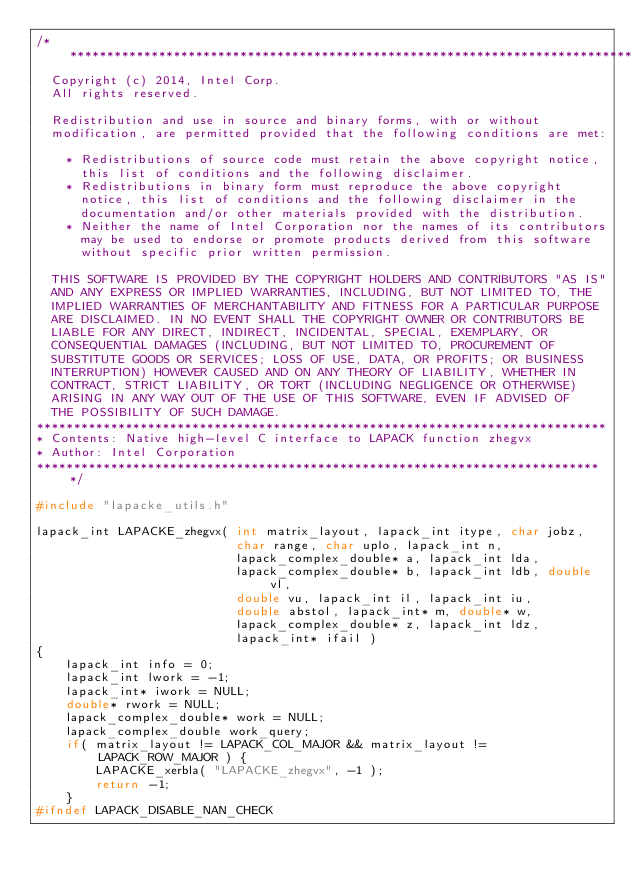Convert code to text. <code><loc_0><loc_0><loc_500><loc_500><_C_>/*****************************************************************************
  Copyright (c) 2014, Intel Corp.
  All rights reserved.

  Redistribution and use in source and binary forms, with or without
  modification, are permitted provided that the following conditions are met:

    * Redistributions of source code must retain the above copyright notice,
      this list of conditions and the following disclaimer.
    * Redistributions in binary form must reproduce the above copyright
      notice, this list of conditions and the following disclaimer in the
      documentation and/or other materials provided with the distribution.
    * Neither the name of Intel Corporation nor the names of its contributors
      may be used to endorse or promote products derived from this software
      without specific prior written permission.

  THIS SOFTWARE IS PROVIDED BY THE COPYRIGHT HOLDERS AND CONTRIBUTORS "AS IS"
  AND ANY EXPRESS OR IMPLIED WARRANTIES, INCLUDING, BUT NOT LIMITED TO, THE
  IMPLIED WARRANTIES OF MERCHANTABILITY AND FITNESS FOR A PARTICULAR PURPOSE
  ARE DISCLAIMED. IN NO EVENT SHALL THE COPYRIGHT OWNER OR CONTRIBUTORS BE
  LIABLE FOR ANY DIRECT, INDIRECT, INCIDENTAL, SPECIAL, EXEMPLARY, OR
  CONSEQUENTIAL DAMAGES (INCLUDING, BUT NOT LIMITED TO, PROCUREMENT OF
  SUBSTITUTE GOODS OR SERVICES; LOSS OF USE, DATA, OR PROFITS; OR BUSINESS
  INTERRUPTION) HOWEVER CAUSED AND ON ANY THEORY OF LIABILITY, WHETHER IN
  CONTRACT, STRICT LIABILITY, OR TORT (INCLUDING NEGLIGENCE OR OTHERWISE)
  ARISING IN ANY WAY OUT OF THE USE OF THIS SOFTWARE, EVEN IF ADVISED OF
  THE POSSIBILITY OF SUCH DAMAGE.
*****************************************************************************
* Contents: Native high-level C interface to LAPACK function zhegvx
* Author: Intel Corporation
*****************************************************************************/

#include "lapacke_utils.h"

lapack_int LAPACKE_zhegvx( int matrix_layout, lapack_int itype, char jobz,
                           char range, char uplo, lapack_int n,
                           lapack_complex_double* a, lapack_int lda,
                           lapack_complex_double* b, lapack_int ldb, double vl,
                           double vu, lapack_int il, lapack_int iu,
                           double abstol, lapack_int* m, double* w,
                           lapack_complex_double* z, lapack_int ldz,
                           lapack_int* ifail )
{
    lapack_int info = 0;
    lapack_int lwork = -1;
    lapack_int* iwork = NULL;
    double* rwork = NULL;
    lapack_complex_double* work = NULL;
    lapack_complex_double work_query;
    if( matrix_layout != LAPACK_COL_MAJOR && matrix_layout != LAPACK_ROW_MAJOR ) {
        LAPACKE_xerbla( "LAPACKE_zhegvx", -1 );
        return -1;
    }
#ifndef LAPACK_DISABLE_NAN_CHECK</code> 